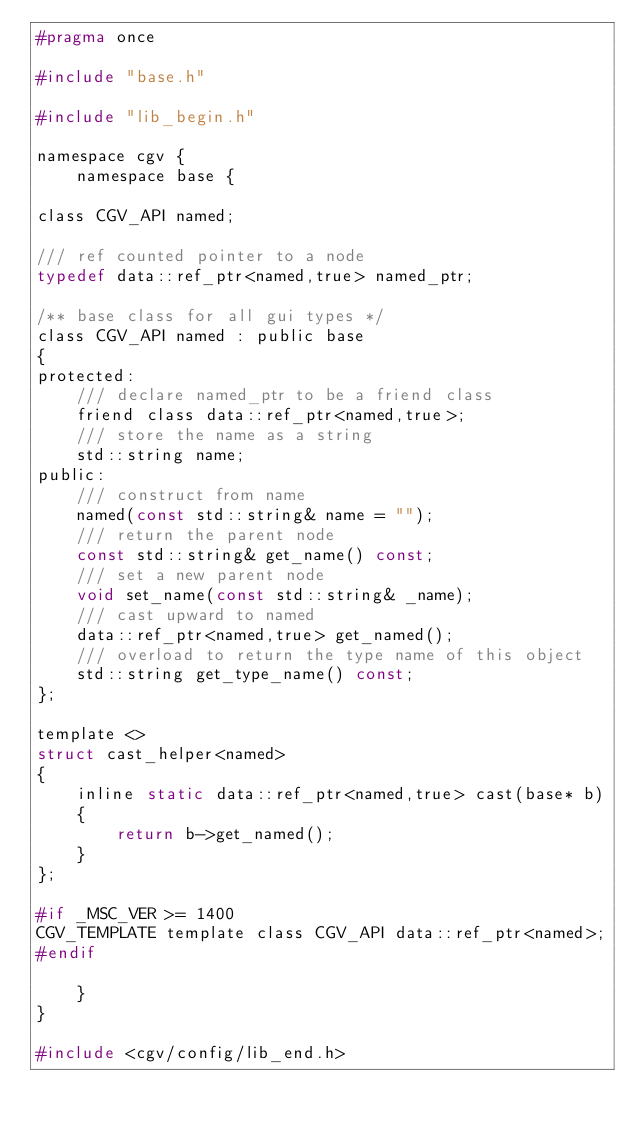Convert code to text. <code><loc_0><loc_0><loc_500><loc_500><_C_>#pragma once

#include "base.h"

#include "lib_begin.h"

namespace cgv {
	namespace base {

class CGV_API named;

/// ref counted pointer to a node
typedef data::ref_ptr<named,true> named_ptr;

/** base class for all gui types */
class CGV_API named : public base
{
protected:
	/// declare named_ptr to be a friend class
	friend class data::ref_ptr<named,true>;
	/// store the name as a string
	std::string name;
public:
	/// construct from name
	named(const std::string& name = "");
	/// return the parent node
	const std::string& get_name() const;
	/// set a new parent node
	void set_name(const std::string& _name);
	/// cast upward to named
	data::ref_ptr<named,true> get_named();
	/// overload to return the type name of this object
	std::string get_type_name() const;
};

template <> 
struct cast_helper<named>
{ 
	inline static data::ref_ptr<named,true> cast(base* b) 
	{ 
		return b->get_named();
	} 
};

#if _MSC_VER >= 1400
CGV_TEMPLATE template class CGV_API data::ref_ptr<named>;
#endif

	}
}

#include <cgv/config/lib_end.h>
</code> 